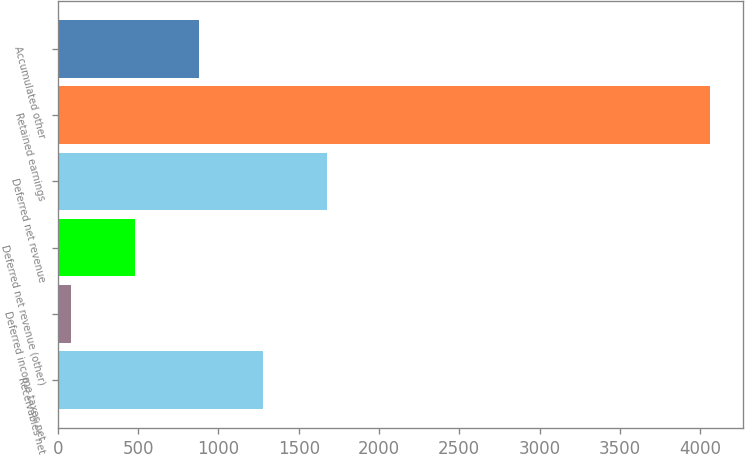Convert chart to OTSL. <chart><loc_0><loc_0><loc_500><loc_500><bar_chart><fcel>Receivables net<fcel>Deferred income taxes net<fcel>Deferred net revenue (other)<fcel>Deferred net revenue<fcel>Retained earnings<fcel>Accumulated other<nl><fcel>1277.4<fcel>84<fcel>481.8<fcel>1675.2<fcel>4062<fcel>879.6<nl></chart> 